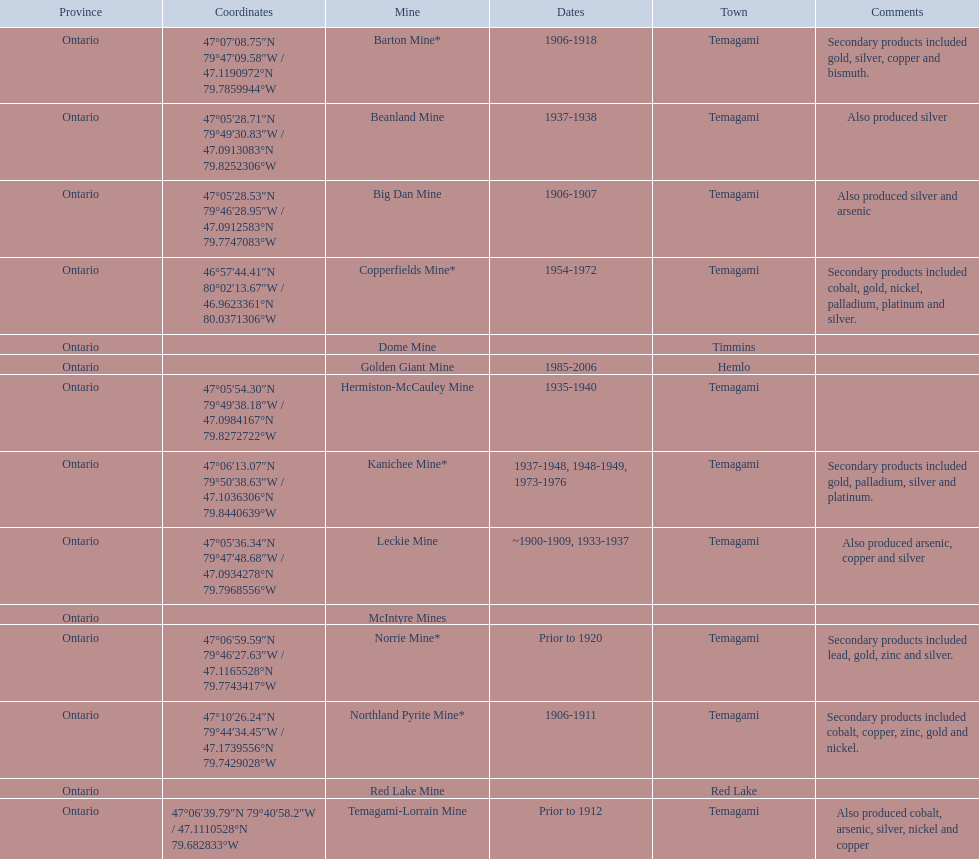What years was the golden giant mine open for? 1985-2006. Parse the table in full. {'header': ['Province', 'Coordinates', 'Mine', 'Dates', 'Town', 'Comments'], 'rows': [['Ontario', '47°07′08.75″N 79°47′09.58″W\ufeff / \ufeff47.1190972°N 79.7859944°W', 'Barton Mine*', '1906-1918', 'Temagami', 'Secondary products included gold, silver, copper and bismuth.'], ['Ontario', '47°05′28.71″N 79°49′30.83″W\ufeff / \ufeff47.0913083°N 79.8252306°W', 'Beanland Mine', '1937-1938', 'Temagami', 'Also produced silver'], ['Ontario', '47°05′28.53″N 79°46′28.95″W\ufeff / \ufeff47.0912583°N 79.7747083°W', 'Big Dan Mine', '1906-1907', 'Temagami', 'Also produced silver and arsenic'], ['Ontario', '46°57′44.41″N 80°02′13.67″W\ufeff / \ufeff46.9623361°N 80.0371306°W', 'Copperfields Mine*', '1954-1972', 'Temagami', 'Secondary products included cobalt, gold, nickel, palladium, platinum and silver.'], ['Ontario', '', 'Dome Mine', '', 'Timmins', ''], ['Ontario', '', 'Golden Giant Mine', '1985-2006', 'Hemlo', ''], ['Ontario', '47°05′54.30″N 79°49′38.18″W\ufeff / \ufeff47.0984167°N 79.8272722°W', 'Hermiston-McCauley Mine', '1935-1940', 'Temagami', ''], ['Ontario', '47°06′13.07″N 79°50′38.63″W\ufeff / \ufeff47.1036306°N 79.8440639°W', 'Kanichee Mine*', '1937-1948, 1948-1949, 1973-1976', 'Temagami', 'Secondary products included gold, palladium, silver and platinum.'], ['Ontario', '47°05′36.34″N 79°47′48.68″W\ufeff / \ufeff47.0934278°N 79.7968556°W', 'Leckie Mine', '~1900-1909, 1933-1937', 'Temagami', 'Also produced arsenic, copper and silver'], ['Ontario', '', 'McIntyre Mines', '', '', ''], ['Ontario', '47°06′59.59″N 79°46′27.63″W\ufeff / \ufeff47.1165528°N 79.7743417°W', 'Norrie Mine*', 'Prior to 1920', 'Temagami', 'Secondary products included lead, gold, zinc and silver.'], ['Ontario', '47°10′26.24″N 79°44′34.45″W\ufeff / \ufeff47.1739556°N 79.7429028°W', 'Northland Pyrite Mine*', '1906-1911', 'Temagami', 'Secondary products included cobalt, copper, zinc, gold and nickel.'], ['Ontario', '', 'Red Lake Mine', '', 'Red Lake', ''], ['Ontario', '47°06′39.79″N 79°40′58.2″W\ufeff / \ufeff47.1110528°N 79.682833°W', 'Temagami-Lorrain Mine', 'Prior to 1912', 'Temagami', 'Also produced cobalt, arsenic, silver, nickel and copper']]} What years was the beanland mine open? 1937-1938. Which of these two mines was open longer? Golden Giant Mine. 